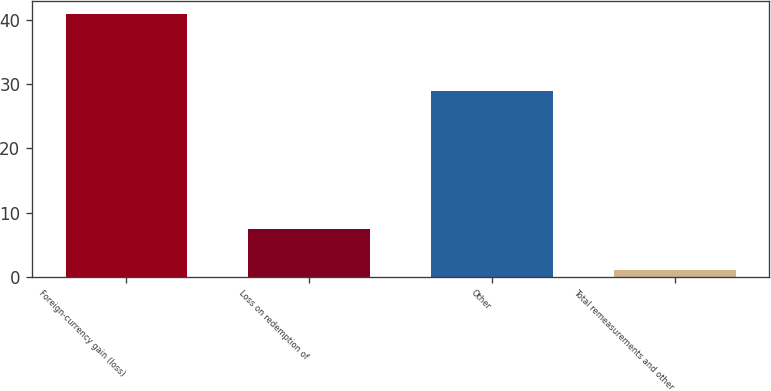Convert chart. <chart><loc_0><loc_0><loc_500><loc_500><bar_chart><fcel>Foreign-currency gain (loss)<fcel>Loss on redemption of<fcel>Other<fcel>Total remeasurements and other<nl><fcel>41<fcel>7.4<fcel>29<fcel>1<nl></chart> 